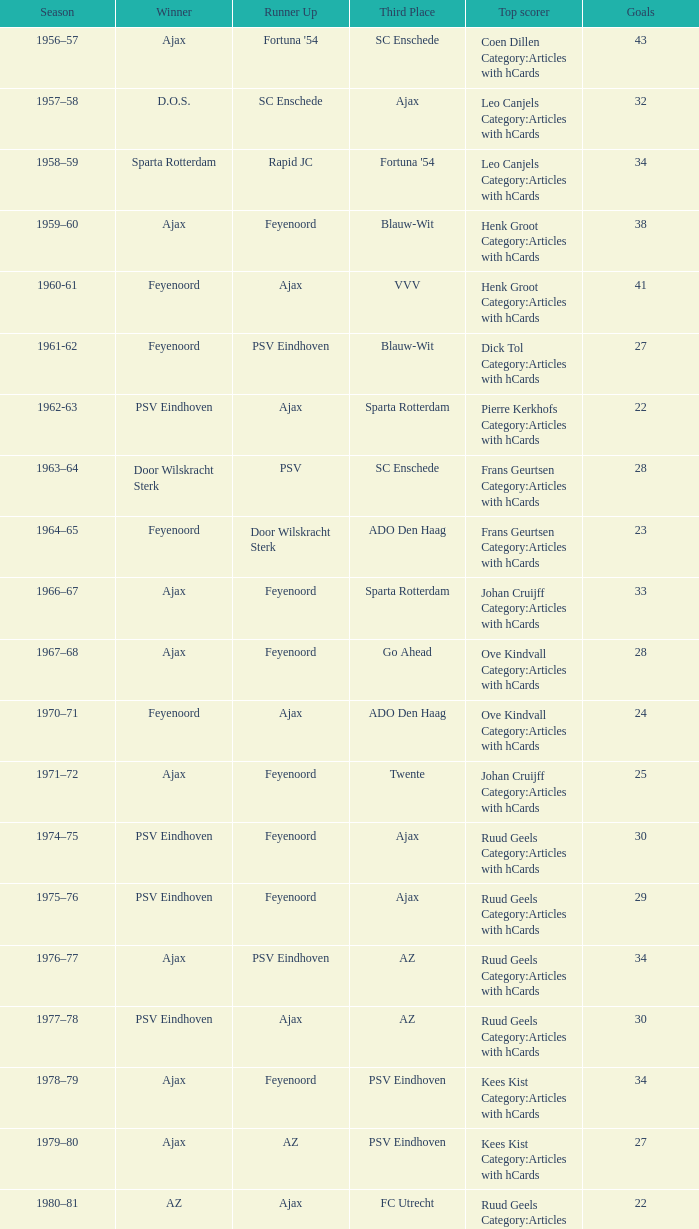When az is the second place and feyenoord took the third position, how many total champions are there? 1.0. 